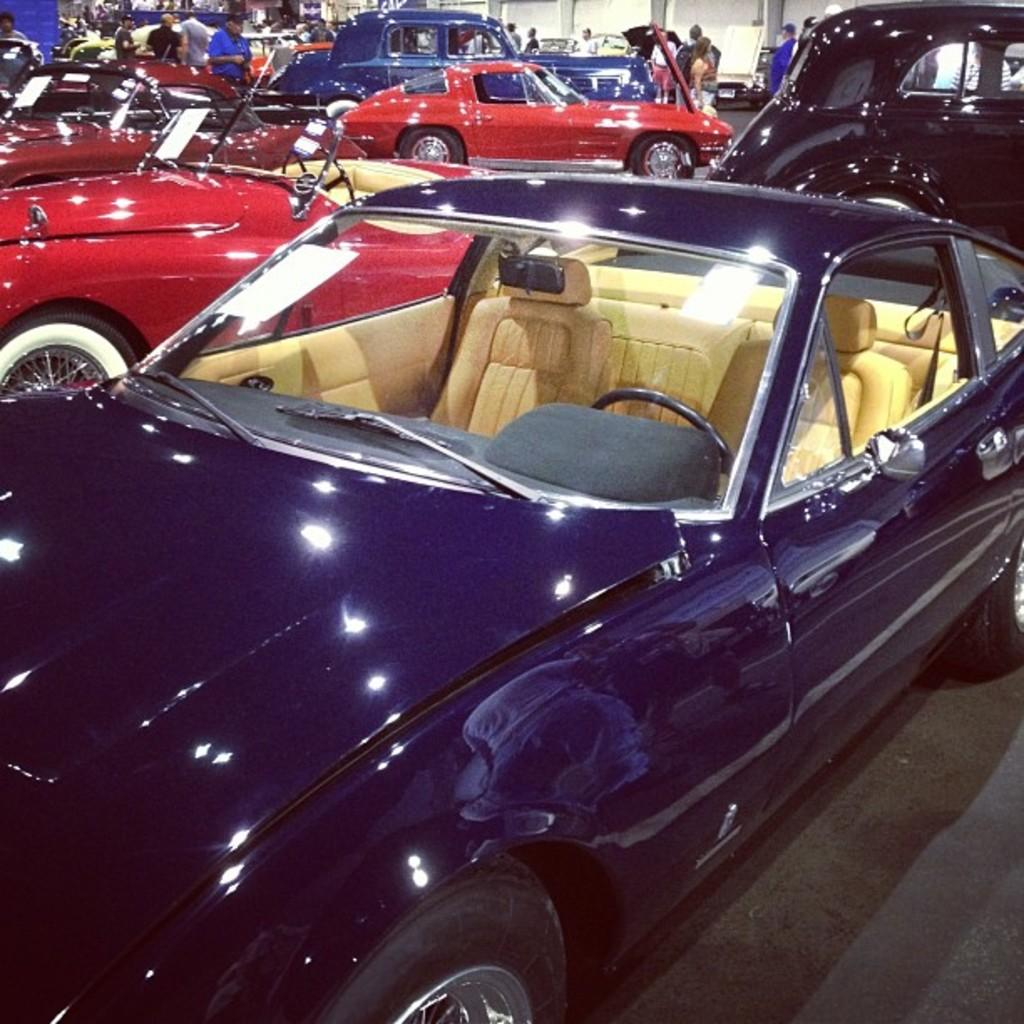What type of vehicles can be seen in the image? There are cars in the image. Can you describe the group of people in the image? There is a group of people in the image. What type of wine is being served in the field with the planes in the image? There is no mention of planes, a field, or wine in the image; it only features cars and a group of people. 